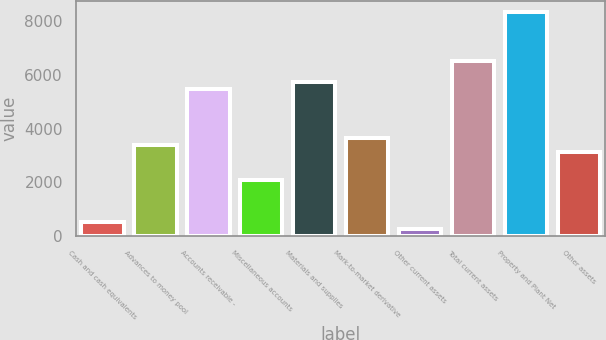Convert chart. <chart><loc_0><loc_0><loc_500><loc_500><bar_chart><fcel>Cash and cash equivalents<fcel>Advances to money pool<fcel>Accounts receivable -<fcel>Miscellaneous accounts<fcel>Materials and supplies<fcel>Mark-to-market derivative<fcel>Other current assets<fcel>Total current assets<fcel>Property and Plant Net<fcel>Other assets<nl><fcel>523.8<fcel>3388.2<fcel>5471.4<fcel>2086.2<fcel>5731.8<fcel>3648.6<fcel>263.4<fcel>6513<fcel>8335.8<fcel>3127.8<nl></chart> 